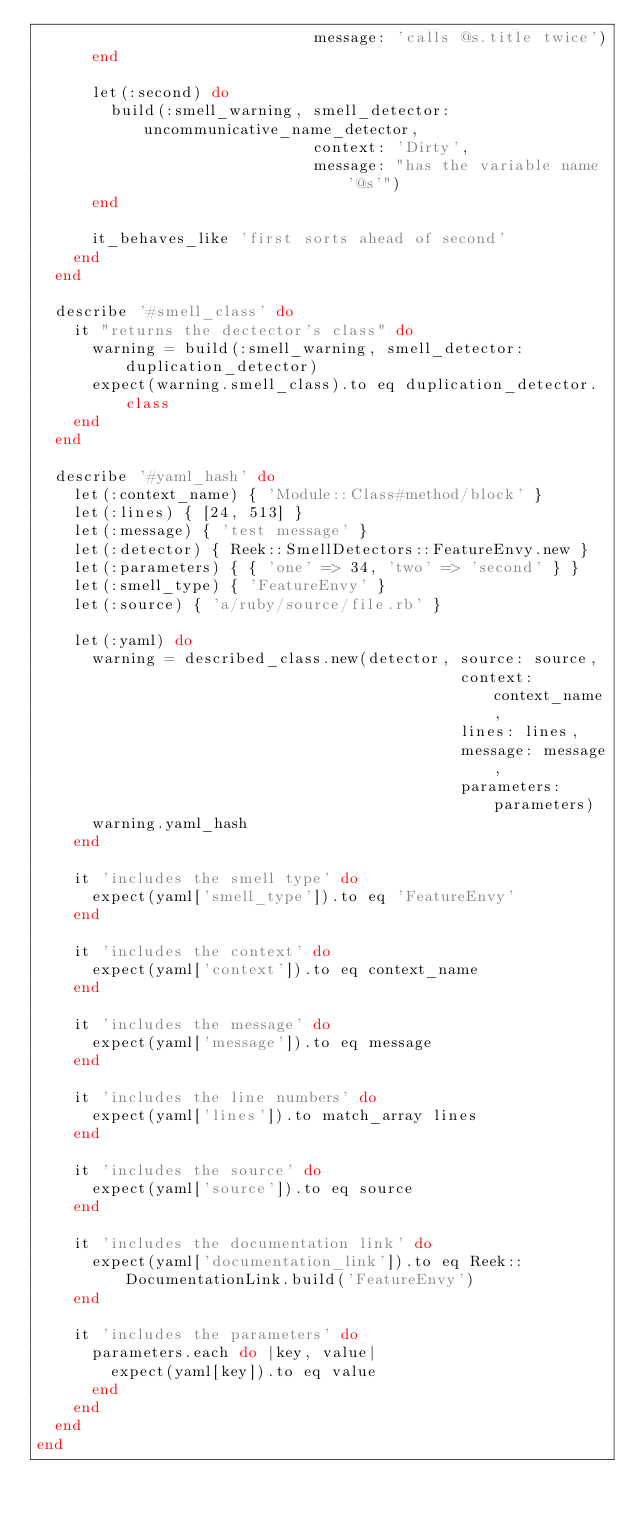<code> <loc_0><loc_0><loc_500><loc_500><_Ruby_>                              message: 'calls @s.title twice')
      end

      let(:second) do
        build(:smell_warning, smell_detector: uncommunicative_name_detector,
                              context: 'Dirty',
                              message: "has the variable name '@s'")
      end

      it_behaves_like 'first sorts ahead of second'
    end
  end

  describe '#smell_class' do
    it "returns the dectector's class" do
      warning = build(:smell_warning, smell_detector: duplication_detector)
      expect(warning.smell_class).to eq duplication_detector.class
    end
  end

  describe '#yaml_hash' do
    let(:context_name) { 'Module::Class#method/block' }
    let(:lines) { [24, 513] }
    let(:message) { 'test message' }
    let(:detector) { Reek::SmellDetectors::FeatureEnvy.new }
    let(:parameters) { { 'one' => 34, 'two' => 'second' } }
    let(:smell_type) { 'FeatureEnvy' }
    let(:source) { 'a/ruby/source/file.rb' }

    let(:yaml) do
      warning = described_class.new(detector, source: source,
                                              context: context_name,
                                              lines: lines,
                                              message: message,
                                              parameters: parameters)
      warning.yaml_hash
    end

    it 'includes the smell type' do
      expect(yaml['smell_type']).to eq 'FeatureEnvy'
    end

    it 'includes the context' do
      expect(yaml['context']).to eq context_name
    end

    it 'includes the message' do
      expect(yaml['message']).to eq message
    end

    it 'includes the line numbers' do
      expect(yaml['lines']).to match_array lines
    end

    it 'includes the source' do
      expect(yaml['source']).to eq source
    end

    it 'includes the documentation link' do
      expect(yaml['documentation_link']).to eq Reek::DocumentationLink.build('FeatureEnvy')
    end

    it 'includes the parameters' do
      parameters.each do |key, value|
        expect(yaml[key]).to eq value
      end
    end
  end
end
</code> 